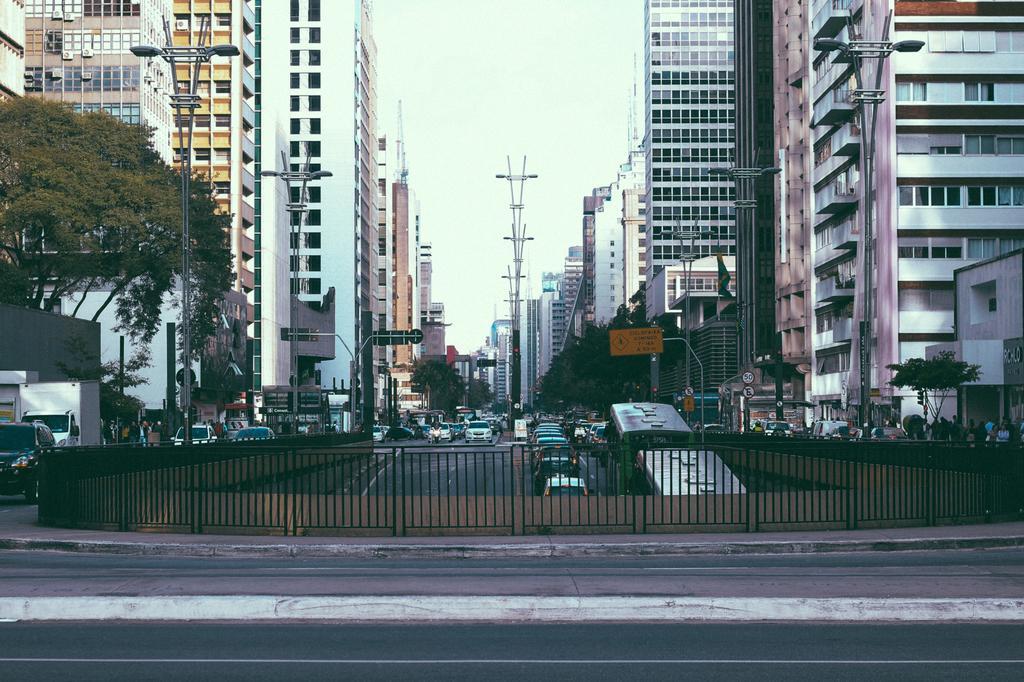Can you describe this image briefly? In front of the image there is a road, beside the road there is a metal grill fence, in front of the fence there are a few vehicles passing on the road, on the either side of the road there are lamp posted, sign boards, traffic lights, trees and buildings. 